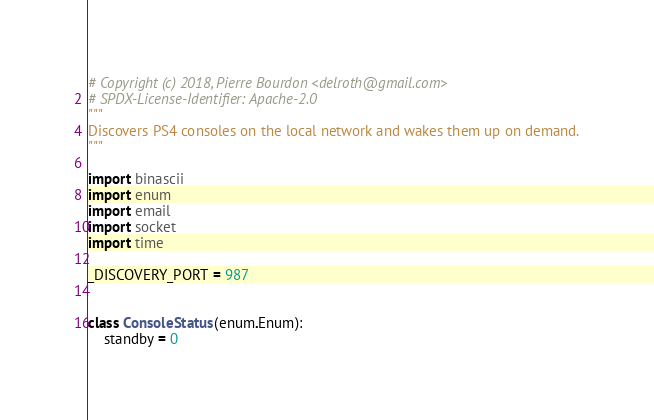<code> <loc_0><loc_0><loc_500><loc_500><_Python_># Copyright (c) 2018, Pierre Bourdon <delroth@gmail.com>
# SPDX-License-Identifier: Apache-2.0
"""
Discovers PS4 consoles on the local network and wakes them up on demand.
"""

import binascii
import enum
import email
import socket
import time

_DISCOVERY_PORT = 987


class ConsoleStatus(enum.Enum):
    standby = 0</code> 